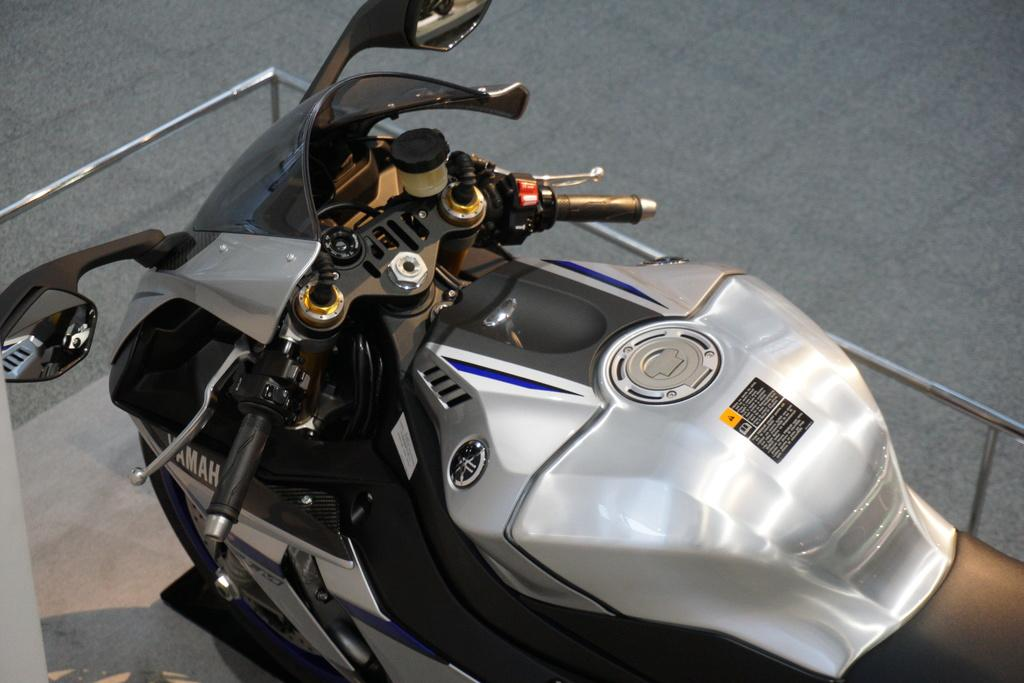What is the main subject in the center of the image? There is a silver color bike in the center of the image. What can be seen in the background of the image? There is a fence in the image. What surface is visible beneath the bike? There is a floor visible in the image. How much debt does the worm have in the image? There is no worm present in the image, so it is not possible to determine any debt associated with it. 